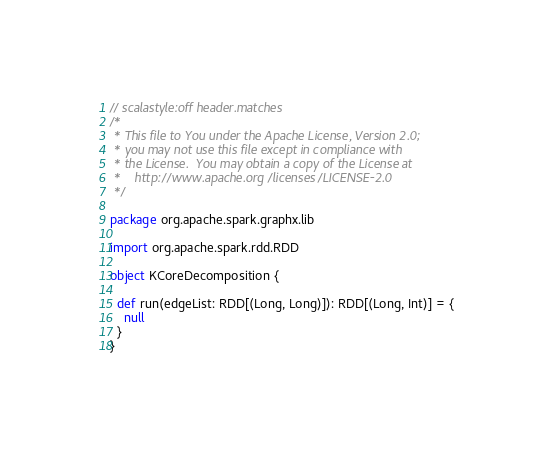<code> <loc_0><loc_0><loc_500><loc_500><_Scala_>// scalastyle:off header.matches
/*
 * This file to You under the Apache License, Version 2.0;
 * you may not use this file except in compliance with
 * the License.  You may obtain a copy of the License at
 *    http://www.apache.org/licenses/LICENSE-2.0
 */

package org.apache.spark.graphx.lib

import org.apache.spark.rdd.RDD

object KCoreDecomposition {

  def run(edgeList: RDD[(Long, Long)]): RDD[(Long, Int)] = {
    null
  }
}
</code> 